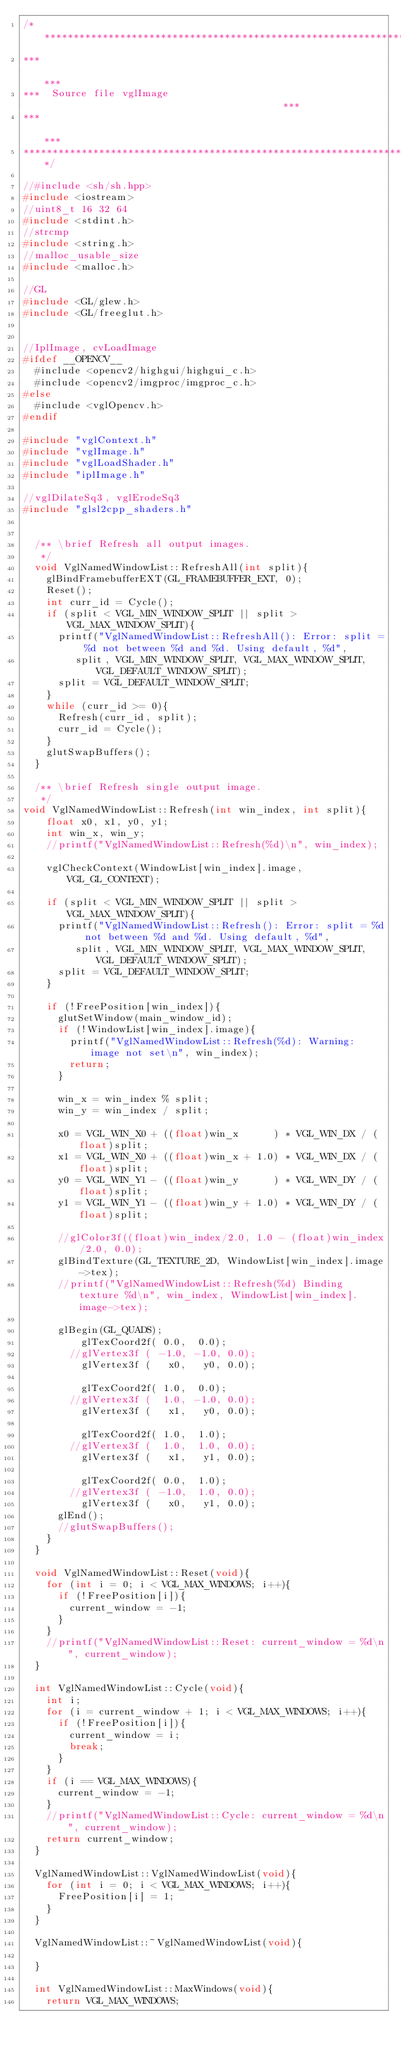<code> <loc_0><loc_0><loc_500><loc_500><_C++_>/*********************************************************************
***                                                                ***
***  Source file vglImage                                          ***
***                                                                ***
*********************************************************************/

//#include <sh/sh.hpp>
#include <iostream>
//uint8_t 16 32 64
#include <stdint.h>
//strcmp
#include <string.h>
//malloc_usable_size
#include <malloc.h>

//GL
#include <GL/glew.h>
#include <GL/freeglut.h>


//IplImage, cvLoadImage
#ifdef __OPENCV__
  #include <opencv2/highgui/highgui_c.h>
  #include <opencv2/imgproc/imgproc_c.h>
#else
  #include <vglOpencv.h>
#endif

#include "vglContext.h"
#include "vglImage.h"
#include "vglLoadShader.h"
#include "iplImage.h"

//vglDilateSq3, vglErodeSq3
#include "glsl2cpp_shaders.h"


  /** \brief Refresh all output images.
   */
  void VglNamedWindowList::RefreshAll(int split){
    glBindFramebufferEXT(GL_FRAMEBUFFER_EXT, 0);
    Reset();
    int curr_id = Cycle();
    if (split < VGL_MIN_WINDOW_SPLIT || split > VGL_MAX_WINDOW_SPLIT){
      printf("VglNamedWindowList::RefreshAll(): Error: split = %d not between %d and %d. Using default, %d",
	     split, VGL_MIN_WINDOW_SPLIT, VGL_MAX_WINDOW_SPLIT, VGL_DEFAULT_WINDOW_SPLIT);
      split = VGL_DEFAULT_WINDOW_SPLIT;
    }
    while (curr_id >= 0){
      Refresh(curr_id, split);
      curr_id = Cycle();
    }
    glutSwapBuffers();
  }

  /** \brief Refresh single output image.
   */
void VglNamedWindowList::Refresh(int win_index, int split){
    float x0, x1, y0, y1;
    int win_x, win_y;
    //printf("VglNamedWindowList::Refresh(%d)\n", win_index);

    vglCheckContext(WindowList[win_index].image, VGL_GL_CONTEXT);

    if (split < VGL_MIN_WINDOW_SPLIT || split > VGL_MAX_WINDOW_SPLIT){
      printf("VglNamedWindowList::Refresh(): Error: split = %d not between %d and %d. Using default, %d",
	     split, VGL_MIN_WINDOW_SPLIT, VGL_MAX_WINDOW_SPLIT, VGL_DEFAULT_WINDOW_SPLIT);
      split = VGL_DEFAULT_WINDOW_SPLIT;
    }

    if (!FreePosition[win_index]){
      glutSetWindow(main_window_id);
      if (!WindowList[win_index].image){
        printf("VglNamedWindowList::Refresh(%d): Warning: image not set\n", win_index);
        return;
      }

      win_x = win_index % split;
      win_y = win_index / split;

      x0 = VGL_WIN_X0 + ((float)win_x      ) * VGL_WIN_DX / (float)split;
      x1 = VGL_WIN_X0 + ((float)win_x + 1.0) * VGL_WIN_DX / (float)split;
      y0 = VGL_WIN_Y1 - ((float)win_y      ) * VGL_WIN_DY / (float)split;
      y1 = VGL_WIN_Y1 - ((float)win_y + 1.0) * VGL_WIN_DY / (float)split;

      //glColor3f((float)win_index/2.0, 1.0 - (float)win_index/2.0, 0.0);
      glBindTexture(GL_TEXTURE_2D, WindowList[win_index].image->tex);
      //printf("VglNamedWindowList::Refresh(%d) Binding texture %d\n", win_index, WindowList[win_index].image->tex);
        
      glBegin(GL_QUADS);
          glTexCoord2f( 0.0,  0.0);
        //glVertex3f ( -1.0, -1.0, 0.0);
          glVertex3f (   x0,   y0, 0.0);

          glTexCoord2f( 1.0,  0.0);
        //glVertex3f (  1.0, -1.0, 0.0);
          glVertex3f (   x1,   y0, 0.0);

          glTexCoord2f( 1.0,  1.0);
        //glVertex3f (  1.0,  1.0, 0.0);
          glVertex3f (   x1,   y1, 0.0);

          glTexCoord2f( 0.0,  1.0);
        //glVertex3f ( -1.0,  1.0, 0.0);
          glVertex3f (   x0,   y1, 0.0);
      glEnd();
      //glutSwapBuffers();
    }
  }

  void VglNamedWindowList::Reset(void){
    for (int i = 0; i < VGL_MAX_WINDOWS; i++){
      if (!FreePosition[i]){
        current_window = -1;
      }
    }    
    //printf("VglNamedWindowList::Reset: current_window = %d\n", current_window);
  }

  int VglNamedWindowList::Cycle(void){
    int i;
    for (i = current_window + 1; i < VGL_MAX_WINDOWS; i++){
      if (!FreePosition[i]){
        current_window = i;
        break;
      }
    }
    if (i == VGL_MAX_WINDOWS){
      current_window = -1;
    }
    //printf("VglNamedWindowList::Cycle: current_window = %d\n", current_window);
    return current_window;
  }

  VglNamedWindowList::VglNamedWindowList(void){
    for (int i = 0; i < VGL_MAX_WINDOWS; i++){
      FreePosition[i] = 1;
    }
  }

  VglNamedWindowList::~VglNamedWindowList(void){

  }

  int VglNamedWindowList::MaxWindows(void){
    return VGL_MAX_WINDOWS;</code> 